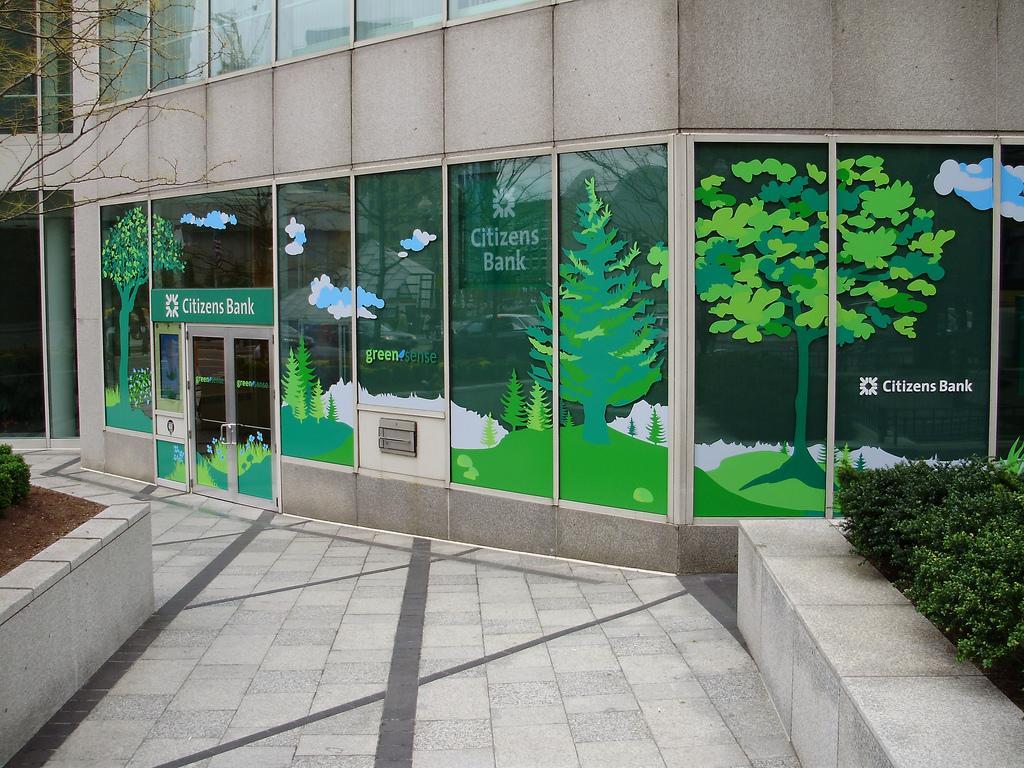Could you give a brief overview of what you see in this image? In the image there is a bank and there is a pavement in front of the bank, there are few plants on the either side of the pavement. 